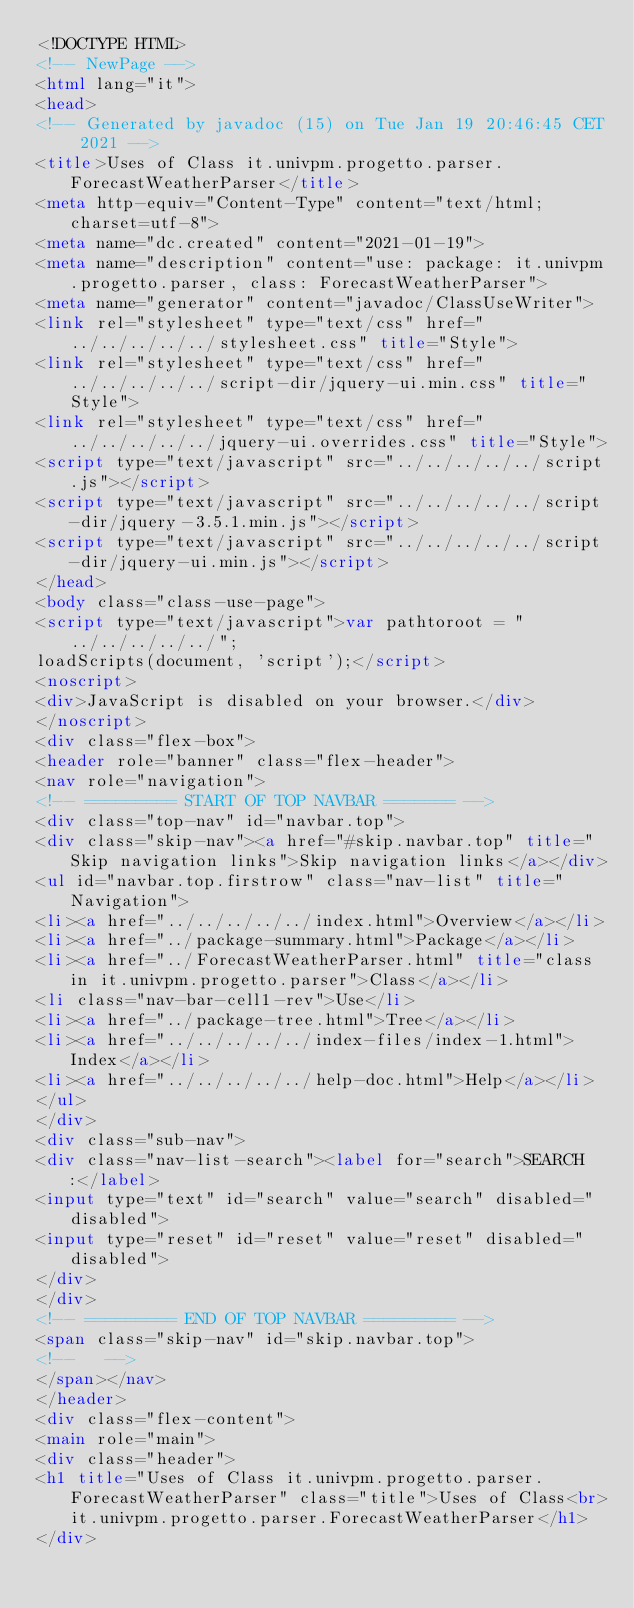Convert code to text. <code><loc_0><loc_0><loc_500><loc_500><_HTML_><!DOCTYPE HTML>
<!-- NewPage -->
<html lang="it">
<head>
<!-- Generated by javadoc (15) on Tue Jan 19 20:46:45 CET 2021 -->
<title>Uses of Class it.univpm.progetto.parser.ForecastWeatherParser</title>
<meta http-equiv="Content-Type" content="text/html; charset=utf-8">
<meta name="dc.created" content="2021-01-19">
<meta name="description" content="use: package: it.univpm.progetto.parser, class: ForecastWeatherParser">
<meta name="generator" content="javadoc/ClassUseWriter">
<link rel="stylesheet" type="text/css" href="../../../../../stylesheet.css" title="Style">
<link rel="stylesheet" type="text/css" href="../../../../../script-dir/jquery-ui.min.css" title="Style">
<link rel="stylesheet" type="text/css" href="../../../../../jquery-ui.overrides.css" title="Style">
<script type="text/javascript" src="../../../../../script.js"></script>
<script type="text/javascript" src="../../../../../script-dir/jquery-3.5.1.min.js"></script>
<script type="text/javascript" src="../../../../../script-dir/jquery-ui.min.js"></script>
</head>
<body class="class-use-page">
<script type="text/javascript">var pathtoroot = "../../../../../";
loadScripts(document, 'script');</script>
<noscript>
<div>JavaScript is disabled on your browser.</div>
</noscript>
<div class="flex-box">
<header role="banner" class="flex-header">
<nav role="navigation">
<!-- ========= START OF TOP NAVBAR ======= -->
<div class="top-nav" id="navbar.top">
<div class="skip-nav"><a href="#skip.navbar.top" title="Skip navigation links">Skip navigation links</a></div>
<ul id="navbar.top.firstrow" class="nav-list" title="Navigation">
<li><a href="../../../../../index.html">Overview</a></li>
<li><a href="../package-summary.html">Package</a></li>
<li><a href="../ForecastWeatherParser.html" title="class in it.univpm.progetto.parser">Class</a></li>
<li class="nav-bar-cell1-rev">Use</li>
<li><a href="../package-tree.html">Tree</a></li>
<li><a href="../../../../../index-files/index-1.html">Index</a></li>
<li><a href="../../../../../help-doc.html">Help</a></li>
</ul>
</div>
<div class="sub-nav">
<div class="nav-list-search"><label for="search">SEARCH:</label>
<input type="text" id="search" value="search" disabled="disabled">
<input type="reset" id="reset" value="reset" disabled="disabled">
</div>
</div>
<!-- ========= END OF TOP NAVBAR ========= -->
<span class="skip-nav" id="skip.navbar.top">
<!--   -->
</span></nav>
</header>
<div class="flex-content">
<main role="main">
<div class="header">
<h1 title="Uses of Class it.univpm.progetto.parser.ForecastWeatherParser" class="title">Uses of Class<br>it.univpm.progetto.parser.ForecastWeatherParser</h1>
</div></code> 